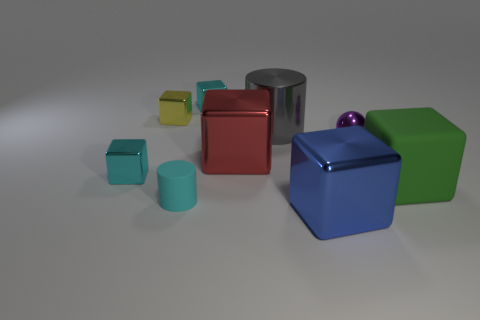What materials are the objects in the image made of? The objects in the image seem to have various materials. The shiny objects, such as the silver cylinder and the small purple sphere, appear to be metallic. The colored cubes look like they have a matte finish, possibly made of a plastic or painted wood. 